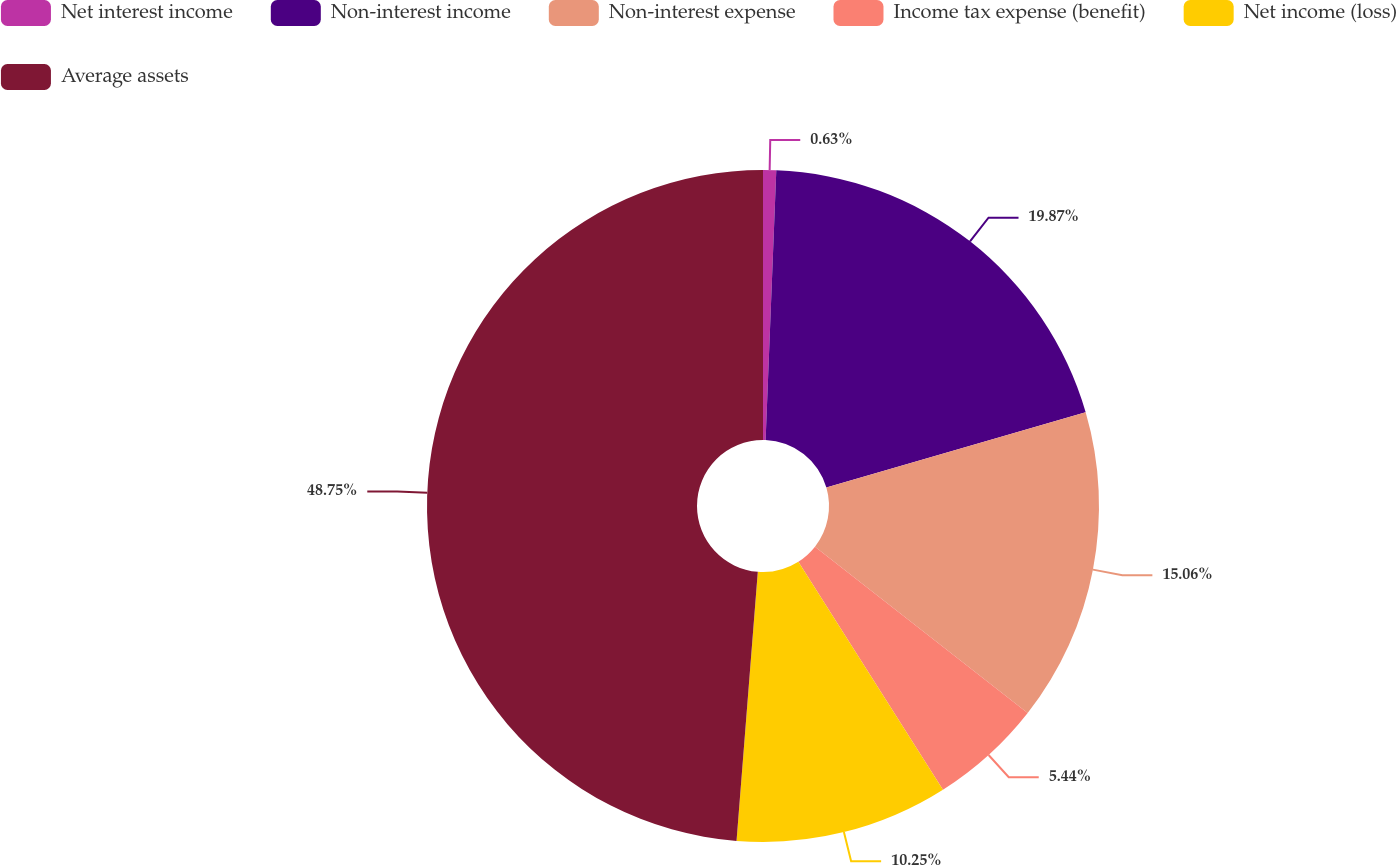Convert chart. <chart><loc_0><loc_0><loc_500><loc_500><pie_chart><fcel>Net interest income<fcel>Non-interest income<fcel>Non-interest expense<fcel>Income tax expense (benefit)<fcel>Net income (loss)<fcel>Average assets<nl><fcel>0.63%<fcel>19.87%<fcel>15.06%<fcel>5.44%<fcel>10.25%<fcel>48.74%<nl></chart> 